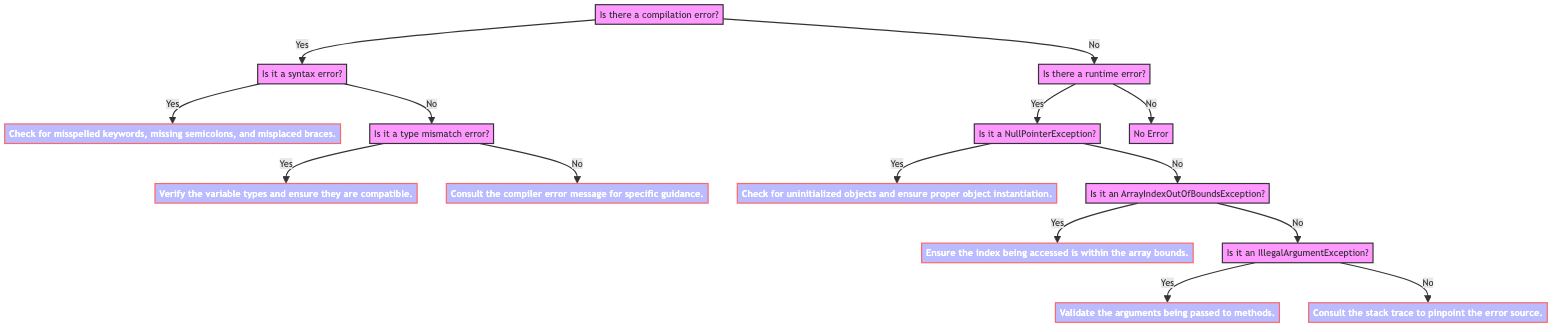Is there a compilation error? The starting point of the decision tree asks whether there is a compilation error. This is the first question at the root of the tree.
Answer: Yes What comes after "Is there a compilation error?" when the answer is No? If there is no compilation error, the next question asked is whether there is a runtime error. This is clearly indicated as a branching path in the tree.
Answer: Is there a runtime error? How many solutions are provided in the tree? The diagram provides four distinct solutions at different paths depending on the type of error identified along the decision paths. Each final path leads to a unique solution after sorting through the types of errors.
Answer: Four What should you do if you encounter a NullPointerException? If the error is identified as a NullPointerException, the solution given is to check for uninitialized objects and ensure proper object instantiation. This solution directly follows the question about the type of runtime error.
Answer: Check for uninitialized objects and ensure proper object instantiation If there’s a type mismatch error, what’s the recommended solution? When a type mismatch error is identified, the solution suggests verifying the variable types and ensuring they are compatible. This is found in the decision pathway detailing type errors.
Answer: Verify the variable types and ensure they are compatible What is the outcome if there is no runtime error? If there is no compilation error or runtime error, the outcome indicated in the diagram is simply "No Error," which shows that there are no issues detected during execution. This is the concluding statement for that decision branch.
Answer: No Error What do you do if you encounter an IllegalArgumentException? Upon encountering an IllegalArgumentException, the advised action is to validate the arguments being passed to methods, which is specified as the solution following that decision node.
Answer: Validate the arguments being passed to methods How do you handle an ArrayIndexOutOfBoundsException? For an ArrayIndexOutOfBoundsException, the solution indicates ensuring that the index being accessed is within the array bounds, representing the necessary clarification following that question.
Answer: Ensure the index being accessed is within the array bounds 